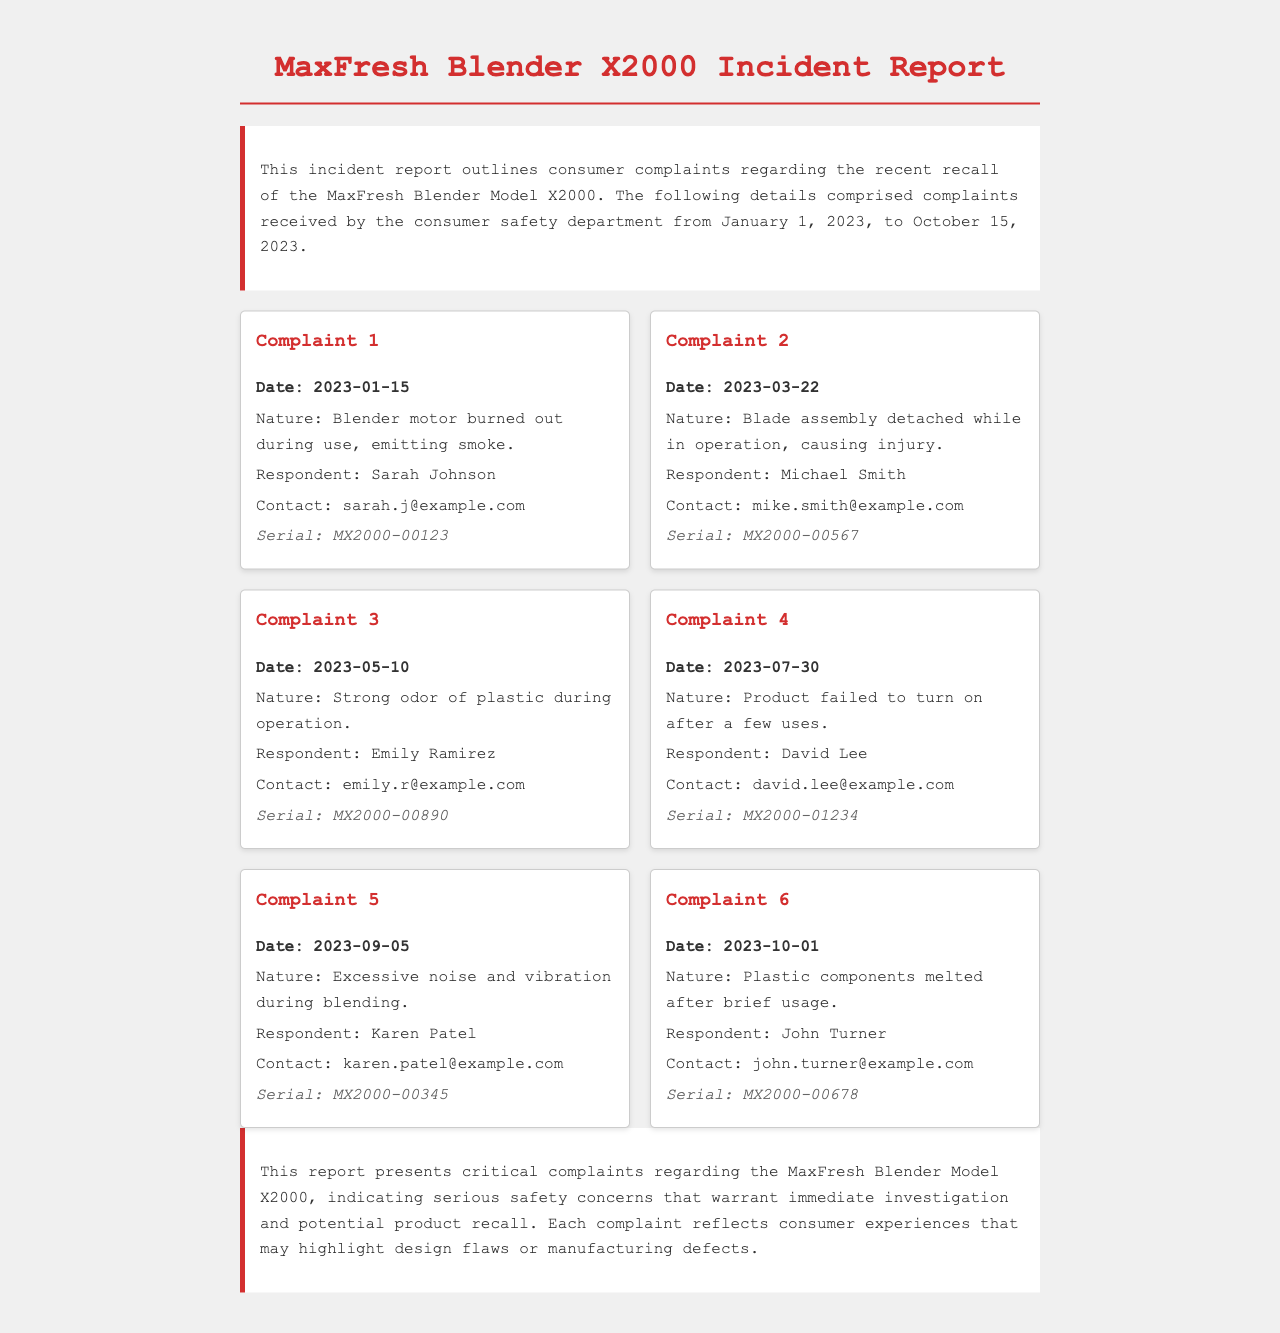What is the model of the blender involved in the recall? The document specifies that the product in question is the MaxFresh Blender Model X2000.
Answer: MaxFresh Blender Model X2000 How many complaints are detailed in the report? The report outlines a total of six consumer complaints regarding the blender.
Answer: 6 Who reported the complaint about the motor burning out? The first complaint about the motor burning out was reported by Sarah Johnson.
Answer: Sarah Johnson What was the nature of the third complaint? The nature of the third complaint was a strong odor of plastic during operation.
Answer: Strong odor of plastic during operation On what date was the complaint regarding excessive noise submitted? The complaint concerning excessive noise was submitted on September 5, 2023.
Answer: 2023-09-05 What issue was associated with David Lee's complaint? David Lee's complaint involved the product failing to turn on after a few uses.
Answer: Product failed to turn on after a few uses What is the primary concern mentioned in the summary of the report? The summary highlights serious safety concerns that warrant immediate investigation.
Answer: Serious safety concerns Which respondent experienced injury due to the blender? The complaint regarding injury was made by Michael Smith.
Answer: Michael Smith 